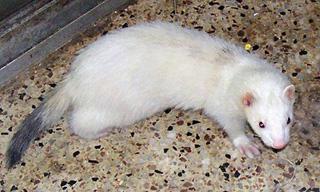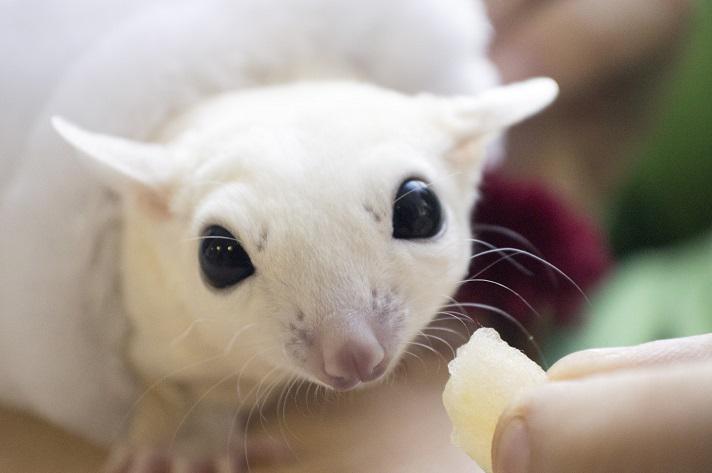The first image is the image on the left, the second image is the image on the right. Assess this claim about the two images: "One ferret is on a rock.". Correct or not? Answer yes or no. No. 